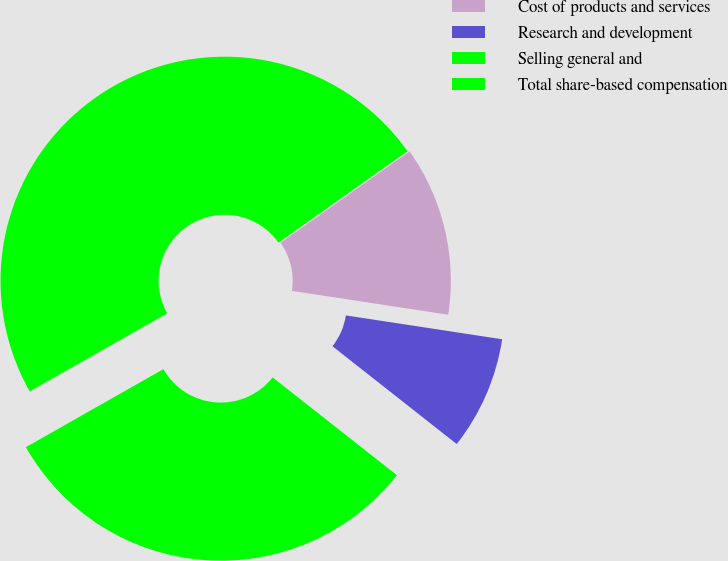<chart> <loc_0><loc_0><loc_500><loc_500><pie_chart><fcel>Cost of products and services<fcel>Research and development<fcel>Selling general and<fcel>Total share-based compensation<nl><fcel>12.22%<fcel>8.2%<fcel>31.17%<fcel>48.4%<nl></chart> 